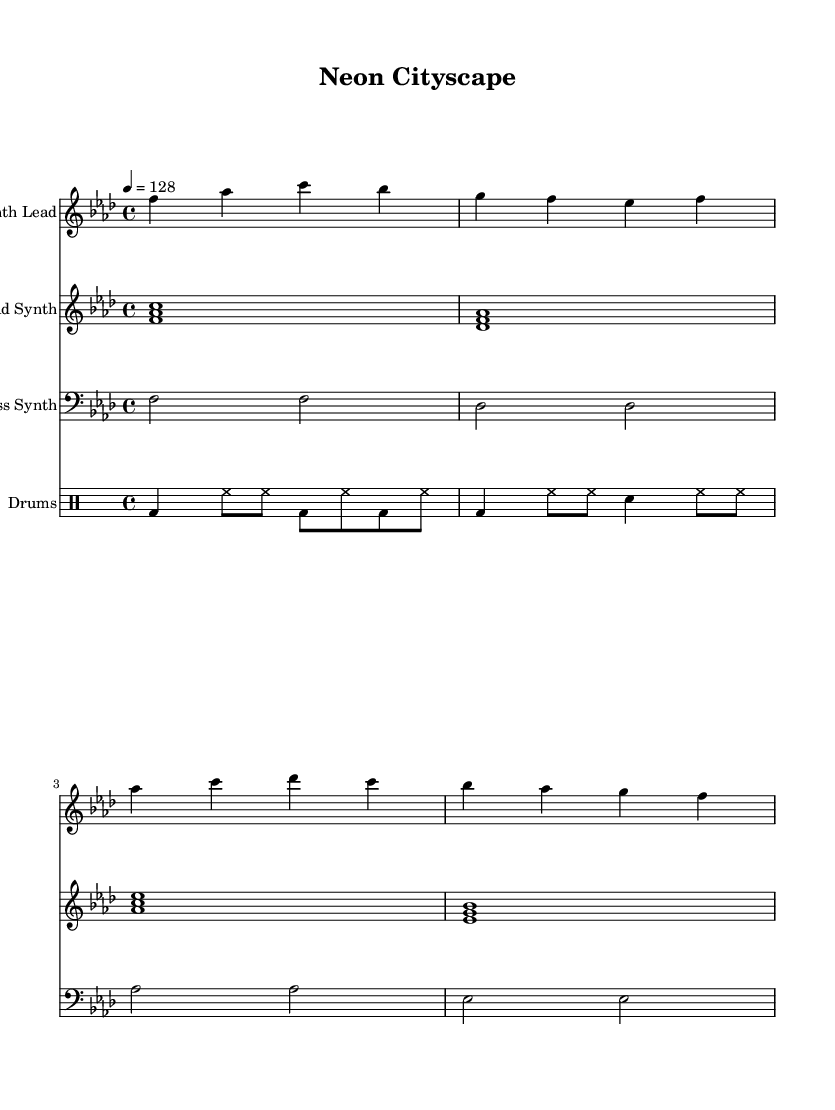What is the key signature of this music? The key signature is F minor, which has four flats (B♭, E♭, A♭, D♭). This can be identified by looking at the placement of the flat symbols at the beginning of the staff.
Answer: F minor What is the time signature of this piece? The time signature is 4/4, as indicated by the notation placed at the beginning of the score. This means there are four beats in each measure, and the quarter note gets one beat.
Answer: 4/4 What is the tempo marking for the piece? The tempo marking indicates a speed of 128 beats per minute, shown by the instruction "4 = 128" in the header section of the sheet music.
Answer: 128 How many measures are in the synthesizer part? The synthesizer part contains four measures, which can be counted by reviewing the complete set of bars shown in the notation.
Answer: 4 What instruments are included in this score? The score includes four instruments: Synth Lead, Pad Synth, Bass Synth, and Drums, identified by their respective staff titles written at the beginning of each staff.
Answer: Synth Lead, Pad Synth, Bass Synth, Drums What is the rhythmic pattern used in the bass synth part? The bass synth part features a played pattern of half notes (two beats each), repeating across each measure. This can be noted by observing the rhythmic values written in that staff area.
Answer: Half notes 